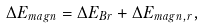Convert formula to latex. <formula><loc_0><loc_0><loc_500><loc_500>\Delta E _ { m a g n } = \Delta E _ { B r } + \Delta E _ { m a g n , r } ,</formula> 